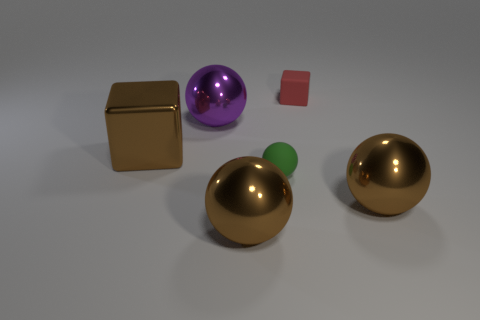Add 2 blue matte cubes. How many objects exist? 8 Subtract all spheres. How many objects are left? 2 Add 2 green matte balls. How many green matte balls are left? 3 Add 6 big blue cubes. How many big blue cubes exist? 6 Subtract 1 brown blocks. How many objects are left? 5 Subtract all small matte objects. Subtract all tiny cylinders. How many objects are left? 4 